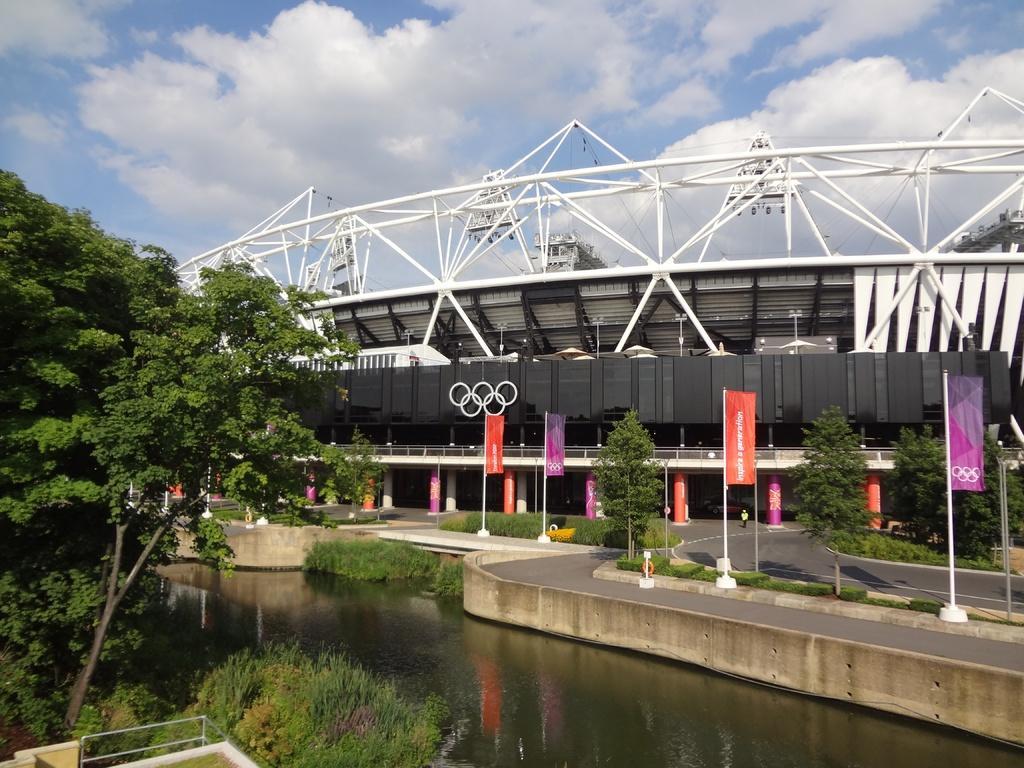How would you summarize this image in a sentence or two? In this picture we can see trees, water, beside the water we can see a road, posters, plants, building, person standing on the ground and we can see sky in the background. 